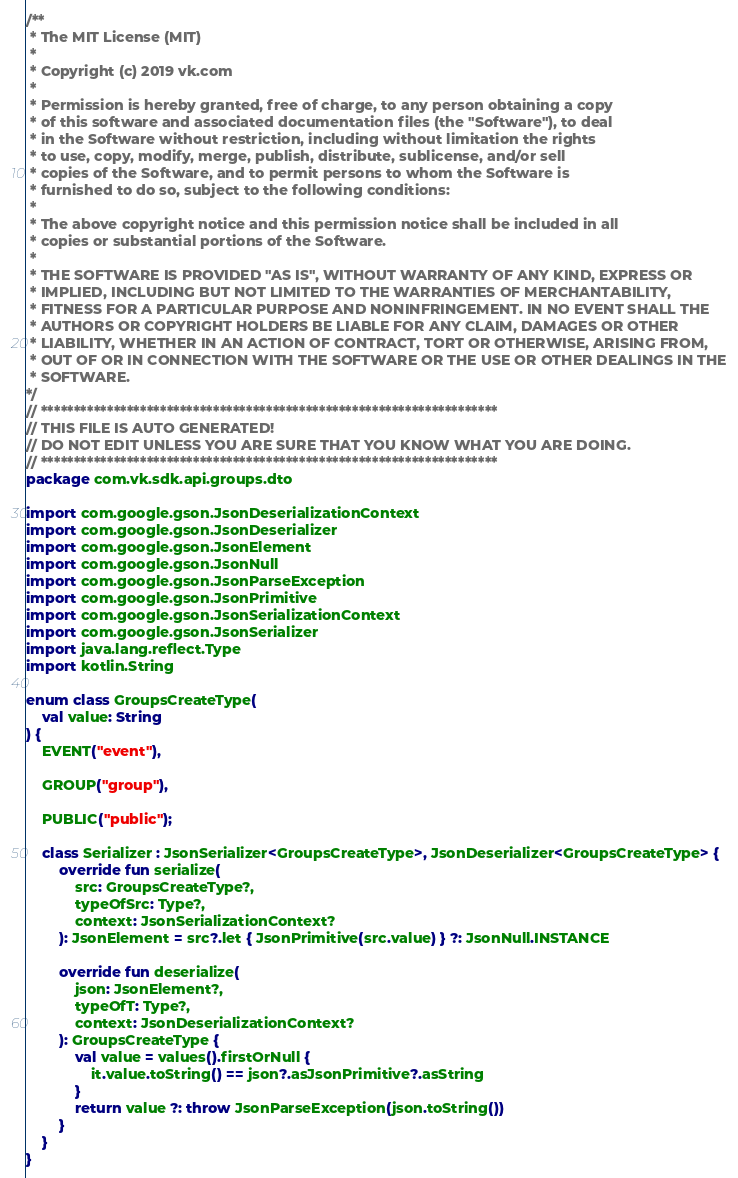<code> <loc_0><loc_0><loc_500><loc_500><_Kotlin_>/**
 * The MIT License (MIT)
 *
 * Copyright (c) 2019 vk.com
 *
 * Permission is hereby granted, free of charge, to any person obtaining a copy
 * of this software and associated documentation files (the "Software"), to deal
 * in the Software without restriction, including without limitation the rights
 * to use, copy, modify, merge, publish, distribute, sublicense, and/or sell
 * copies of the Software, and to permit persons to whom the Software is
 * furnished to do so, subject to the following conditions:
 *
 * The above copyright notice and this permission notice shall be included in all
 * copies or substantial portions of the Software.
 *
 * THE SOFTWARE IS PROVIDED "AS IS", WITHOUT WARRANTY OF ANY KIND, EXPRESS OR
 * IMPLIED, INCLUDING BUT NOT LIMITED TO THE WARRANTIES OF MERCHANTABILITY,
 * FITNESS FOR A PARTICULAR PURPOSE AND NONINFRINGEMENT. IN NO EVENT SHALL THE
 * AUTHORS OR COPYRIGHT HOLDERS BE LIABLE FOR ANY CLAIM, DAMAGES OR OTHER
 * LIABILITY, WHETHER IN AN ACTION OF CONTRACT, TORT OR OTHERWISE, ARISING FROM,
 * OUT OF OR IN CONNECTION WITH THE SOFTWARE OR THE USE OR OTHER DEALINGS IN THE
 * SOFTWARE.
*/
// *********************************************************************
// THIS FILE IS AUTO GENERATED!
// DO NOT EDIT UNLESS YOU ARE SURE THAT YOU KNOW WHAT YOU ARE DOING.
// *********************************************************************
package com.vk.sdk.api.groups.dto

import com.google.gson.JsonDeserializationContext
import com.google.gson.JsonDeserializer
import com.google.gson.JsonElement
import com.google.gson.JsonNull
import com.google.gson.JsonParseException
import com.google.gson.JsonPrimitive
import com.google.gson.JsonSerializationContext
import com.google.gson.JsonSerializer
import java.lang.reflect.Type
import kotlin.String

enum class GroupsCreateType(
    val value: String
) {
    EVENT("event"),

    GROUP("group"),

    PUBLIC("public");

    class Serializer : JsonSerializer<GroupsCreateType>, JsonDeserializer<GroupsCreateType> {
        override fun serialize(
            src: GroupsCreateType?,
            typeOfSrc: Type?,
            context: JsonSerializationContext?
        ): JsonElement = src?.let { JsonPrimitive(src.value) } ?: JsonNull.INSTANCE

        override fun deserialize(
            json: JsonElement?,
            typeOfT: Type?,
            context: JsonDeserializationContext?
        ): GroupsCreateType {
            val value = values().firstOrNull {
                it.value.toString() == json?.asJsonPrimitive?.asString
            }
            return value ?: throw JsonParseException(json.toString())
        }
    }
}
</code> 